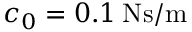<formula> <loc_0><loc_0><loc_500><loc_500>c _ { 0 } = 0 . 1 \, N s / m</formula> 